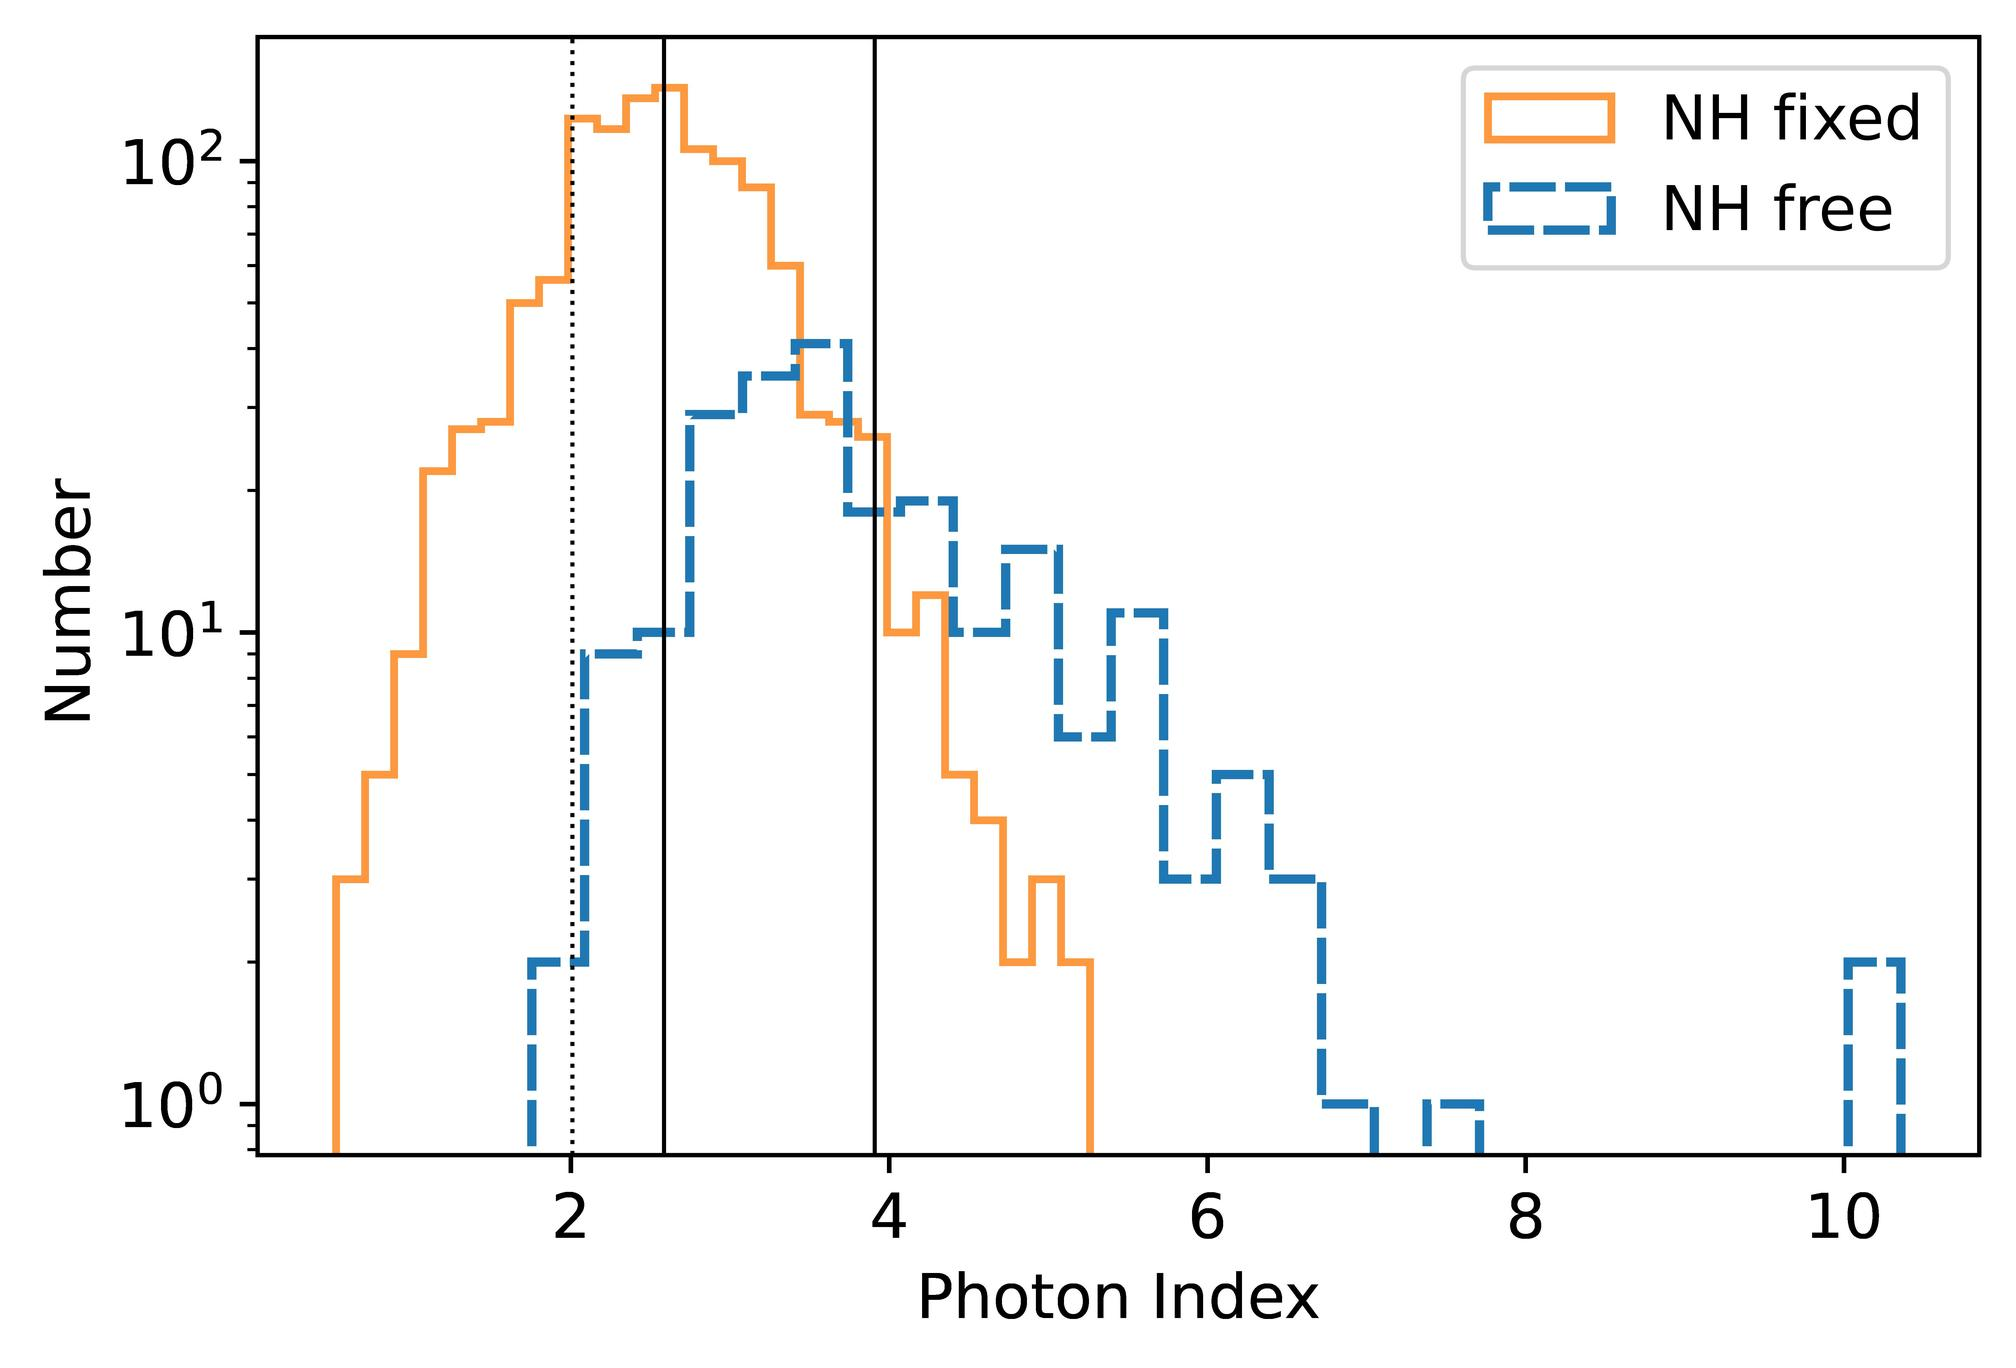Can you explain what might cause the difference in distribution between NH fixed and NH free? The difference in distributions between NH fixed and NH free, as seen in the histogram, suggests variations in how each parameter models the data. 'NH fixed' might represent a scenario where a certain parameter (like hydrogen column density in astrophysical studies) is kept constant, allowing us to observe effects of other varying conditions. 'NH free,' on the other hand, indicates that this parameter is variable, providing a broader range of data. These differences could lead to the peaks and troughs observed in their respective distributions, offering insights into the impact of this parameter on the measured phenomena. 